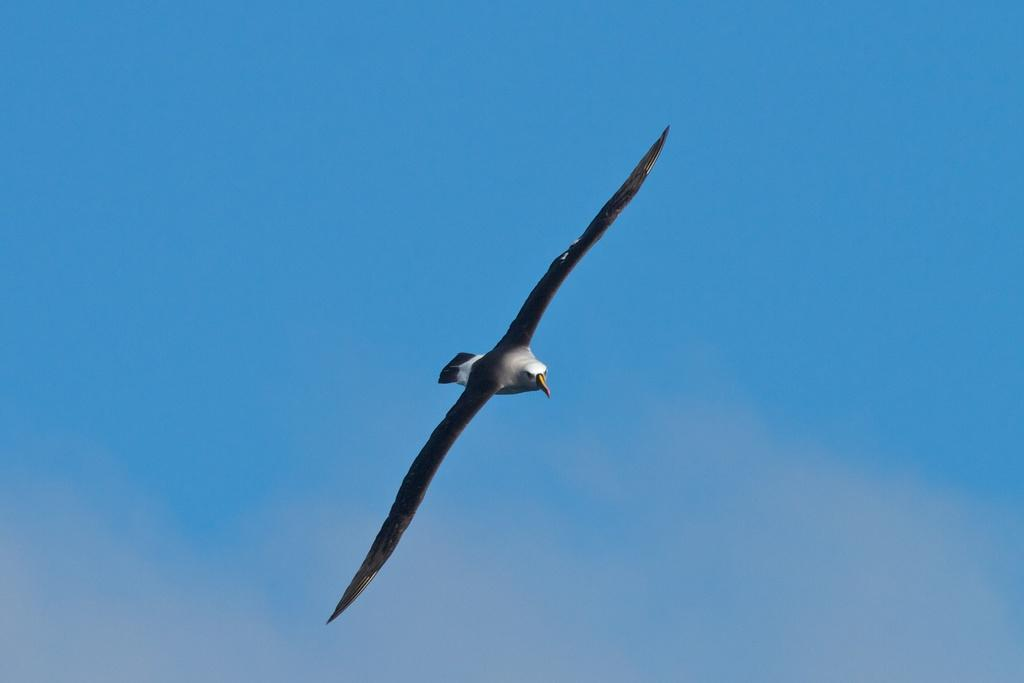What is the main subject of the image? There is a bird flying in the image. What can be observed about the bird's movement? The bird is flying in the image. What is the color of the background in the image? The background of the image appears to be blue in color. What type of trade is being conducted by the bird in the image? There is no indication of any trade being conducted in the image; it simply shows a bird flying. What does the bird's mouth look like in the image? The image does not show the bird's mouth, as it is focused on the bird flying. 